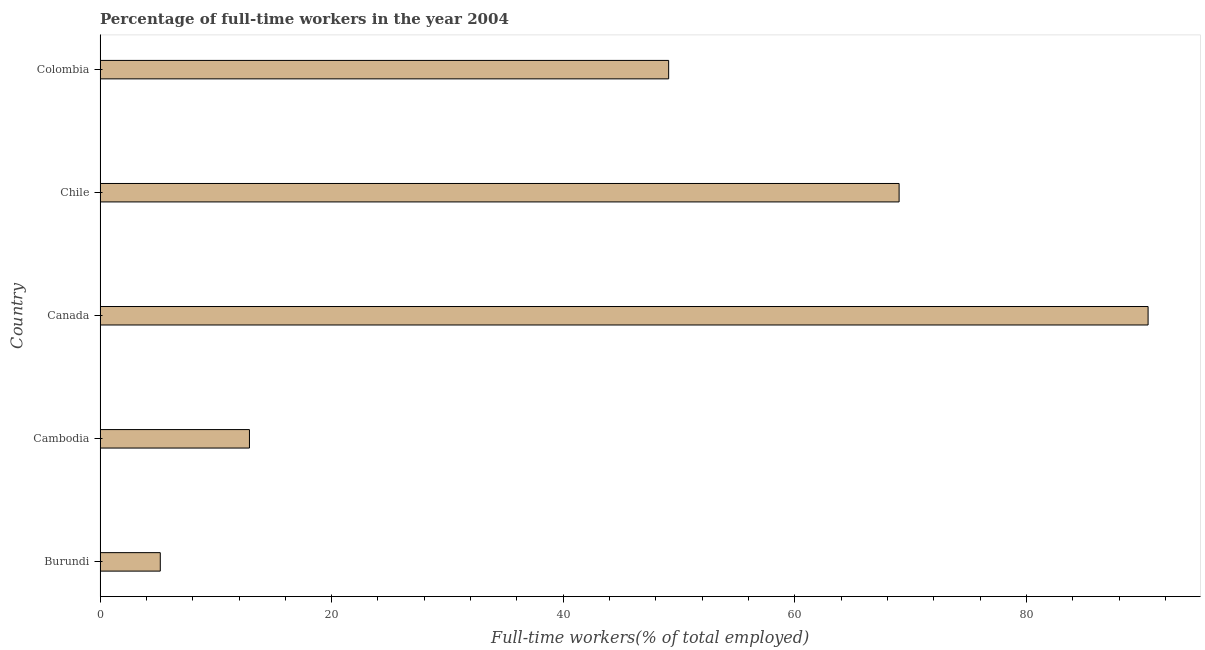Does the graph contain any zero values?
Your answer should be very brief. No. Does the graph contain grids?
Offer a very short reply. No. What is the title of the graph?
Your answer should be very brief. Percentage of full-time workers in the year 2004. What is the label or title of the X-axis?
Your answer should be compact. Full-time workers(% of total employed). What is the percentage of full-time workers in Burundi?
Offer a very short reply. 5.2. Across all countries, what is the maximum percentage of full-time workers?
Provide a short and direct response. 90.5. Across all countries, what is the minimum percentage of full-time workers?
Your answer should be compact. 5.2. In which country was the percentage of full-time workers minimum?
Provide a succinct answer. Burundi. What is the sum of the percentage of full-time workers?
Your answer should be very brief. 226.7. What is the difference between the percentage of full-time workers in Cambodia and Canada?
Keep it short and to the point. -77.6. What is the average percentage of full-time workers per country?
Provide a short and direct response. 45.34. What is the median percentage of full-time workers?
Offer a terse response. 49.1. In how many countries, is the percentage of full-time workers greater than 12 %?
Make the answer very short. 4. What is the ratio of the percentage of full-time workers in Burundi to that in Chile?
Offer a terse response. 0.07. What is the difference between the highest and the lowest percentage of full-time workers?
Your answer should be very brief. 85.3. In how many countries, is the percentage of full-time workers greater than the average percentage of full-time workers taken over all countries?
Your response must be concise. 3. How many bars are there?
Make the answer very short. 5. What is the difference between two consecutive major ticks on the X-axis?
Offer a very short reply. 20. Are the values on the major ticks of X-axis written in scientific E-notation?
Offer a very short reply. No. What is the Full-time workers(% of total employed) in Burundi?
Offer a terse response. 5.2. What is the Full-time workers(% of total employed) in Cambodia?
Your answer should be very brief. 12.9. What is the Full-time workers(% of total employed) in Canada?
Offer a terse response. 90.5. What is the Full-time workers(% of total employed) of Colombia?
Give a very brief answer. 49.1. What is the difference between the Full-time workers(% of total employed) in Burundi and Canada?
Your answer should be compact. -85.3. What is the difference between the Full-time workers(% of total employed) in Burundi and Chile?
Provide a succinct answer. -63.8. What is the difference between the Full-time workers(% of total employed) in Burundi and Colombia?
Provide a short and direct response. -43.9. What is the difference between the Full-time workers(% of total employed) in Cambodia and Canada?
Provide a succinct answer. -77.6. What is the difference between the Full-time workers(% of total employed) in Cambodia and Chile?
Ensure brevity in your answer.  -56.1. What is the difference between the Full-time workers(% of total employed) in Cambodia and Colombia?
Make the answer very short. -36.2. What is the difference between the Full-time workers(% of total employed) in Canada and Chile?
Provide a succinct answer. 21.5. What is the difference between the Full-time workers(% of total employed) in Canada and Colombia?
Offer a terse response. 41.4. What is the difference between the Full-time workers(% of total employed) in Chile and Colombia?
Your answer should be very brief. 19.9. What is the ratio of the Full-time workers(% of total employed) in Burundi to that in Cambodia?
Offer a terse response. 0.4. What is the ratio of the Full-time workers(% of total employed) in Burundi to that in Canada?
Offer a very short reply. 0.06. What is the ratio of the Full-time workers(% of total employed) in Burundi to that in Chile?
Make the answer very short. 0.07. What is the ratio of the Full-time workers(% of total employed) in Burundi to that in Colombia?
Offer a terse response. 0.11. What is the ratio of the Full-time workers(% of total employed) in Cambodia to that in Canada?
Your answer should be very brief. 0.14. What is the ratio of the Full-time workers(% of total employed) in Cambodia to that in Chile?
Ensure brevity in your answer.  0.19. What is the ratio of the Full-time workers(% of total employed) in Cambodia to that in Colombia?
Ensure brevity in your answer.  0.26. What is the ratio of the Full-time workers(% of total employed) in Canada to that in Chile?
Your answer should be compact. 1.31. What is the ratio of the Full-time workers(% of total employed) in Canada to that in Colombia?
Provide a succinct answer. 1.84. What is the ratio of the Full-time workers(% of total employed) in Chile to that in Colombia?
Your answer should be compact. 1.41. 